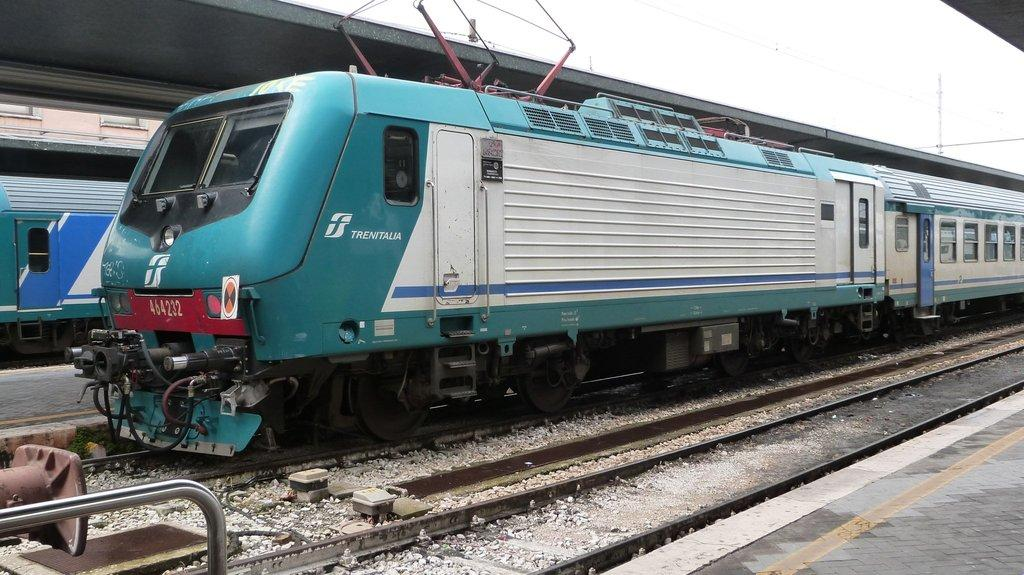<image>
Present a compact description of the photo's key features. A blue and white train has the logo forTrentalia on the front side. 